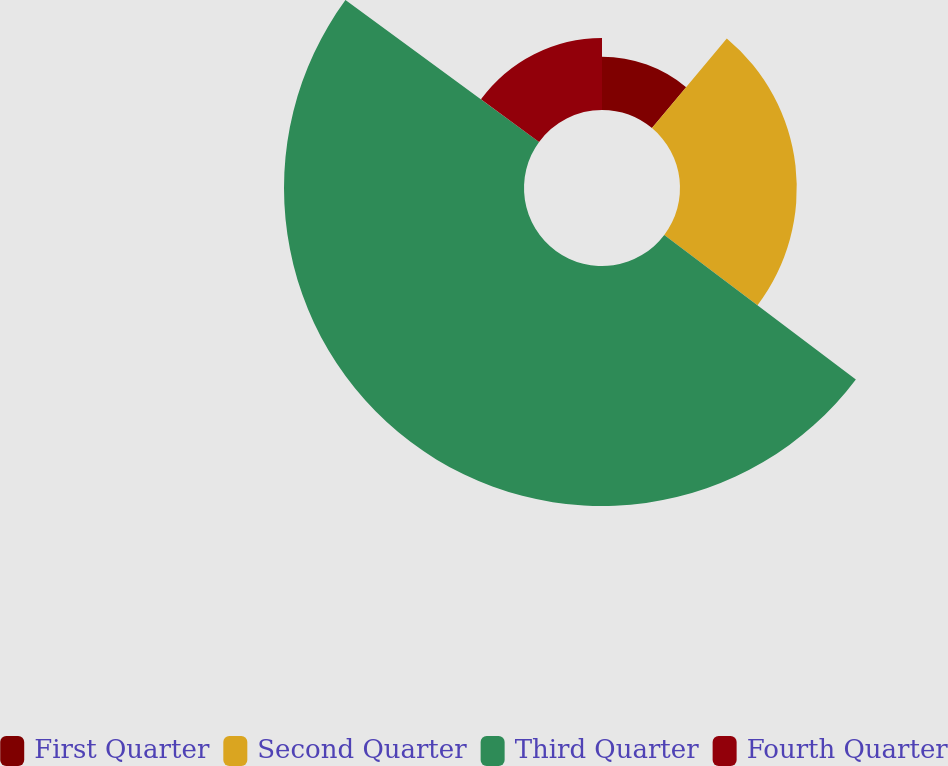Convert chart to OTSL. <chart><loc_0><loc_0><loc_500><loc_500><pie_chart><fcel>First Quarter<fcel>Second Quarter<fcel>Third Quarter<fcel>Fourth Quarter<nl><fcel>11.07%<fcel>24.22%<fcel>49.78%<fcel>14.94%<nl></chart> 